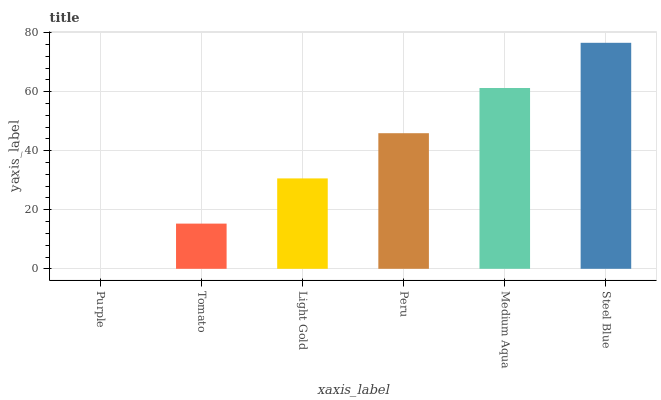Is Purple the minimum?
Answer yes or no. Yes. Is Steel Blue the maximum?
Answer yes or no. Yes. Is Tomato the minimum?
Answer yes or no. No. Is Tomato the maximum?
Answer yes or no. No. Is Tomato greater than Purple?
Answer yes or no. Yes. Is Purple less than Tomato?
Answer yes or no. Yes. Is Purple greater than Tomato?
Answer yes or no. No. Is Tomato less than Purple?
Answer yes or no. No. Is Peru the high median?
Answer yes or no. Yes. Is Light Gold the low median?
Answer yes or no. Yes. Is Steel Blue the high median?
Answer yes or no. No. Is Steel Blue the low median?
Answer yes or no. No. 